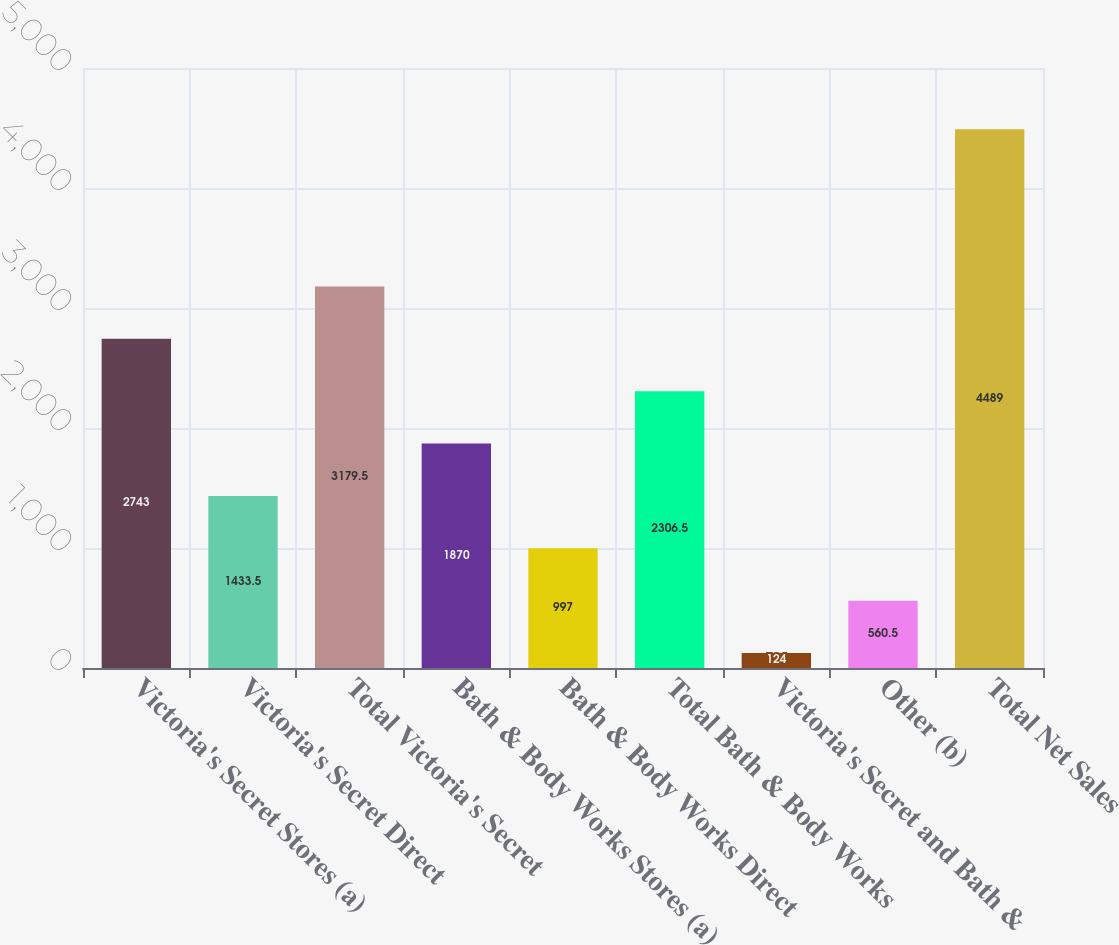Convert chart. <chart><loc_0><loc_0><loc_500><loc_500><bar_chart><fcel>Victoria's Secret Stores (a)<fcel>Victoria's Secret Direct<fcel>Total Victoria's Secret<fcel>Bath & Body Works Stores (a)<fcel>Bath & Body Works Direct<fcel>Total Bath & Body Works<fcel>Victoria's Secret and Bath &<fcel>Other (b)<fcel>Total Net Sales<nl><fcel>2743<fcel>1433.5<fcel>3179.5<fcel>1870<fcel>997<fcel>2306.5<fcel>124<fcel>560.5<fcel>4489<nl></chart> 